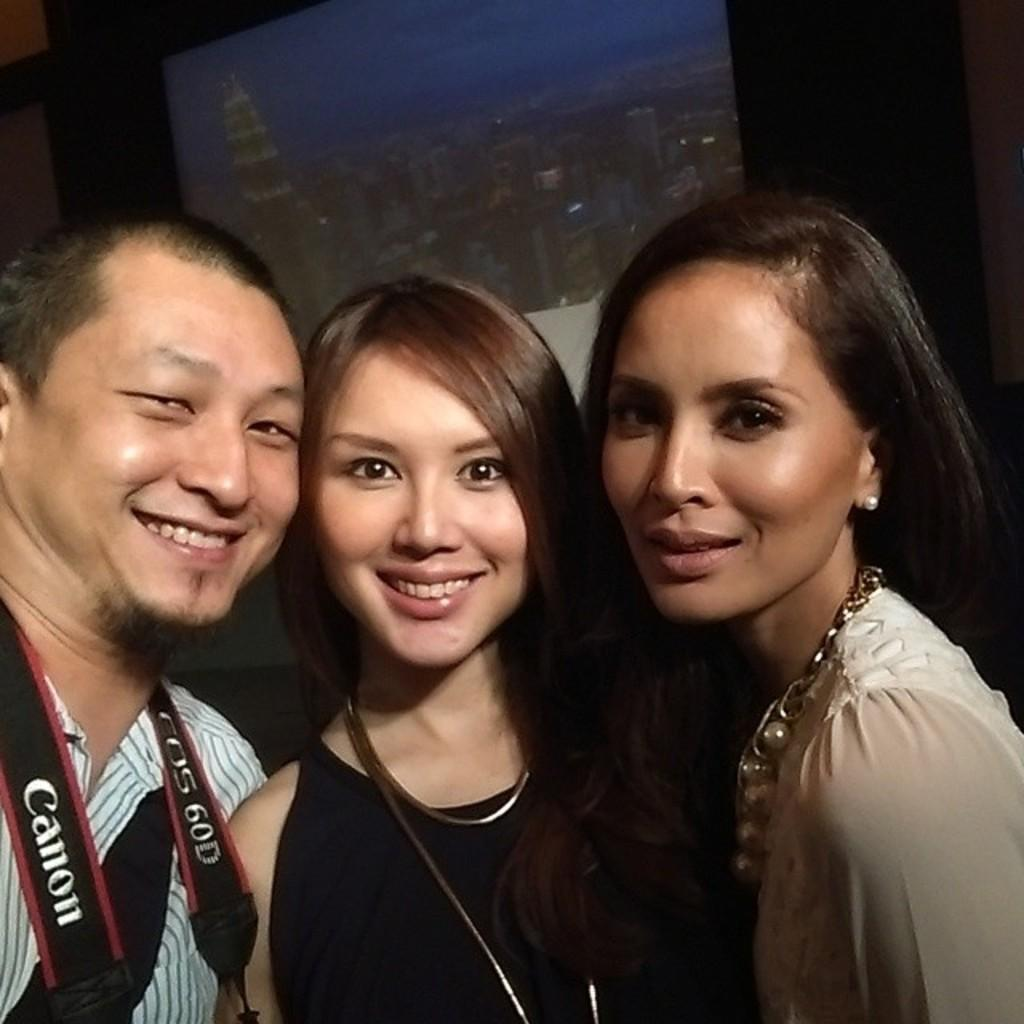How many people are in the image? There are two women and one man in the image. What are the individuals doing in the image? The individuals are standing and smiling. What are the women wearing in the image? The women are wearing ornaments. What is the man wearing in the image? The man is wearing a camera belt. What type of jewel is the man playing on his guitar in the image? There is no guitar or jewel present in the image. What type of bulb is hanging above the individuals in the image? There is no bulb present in the image. 